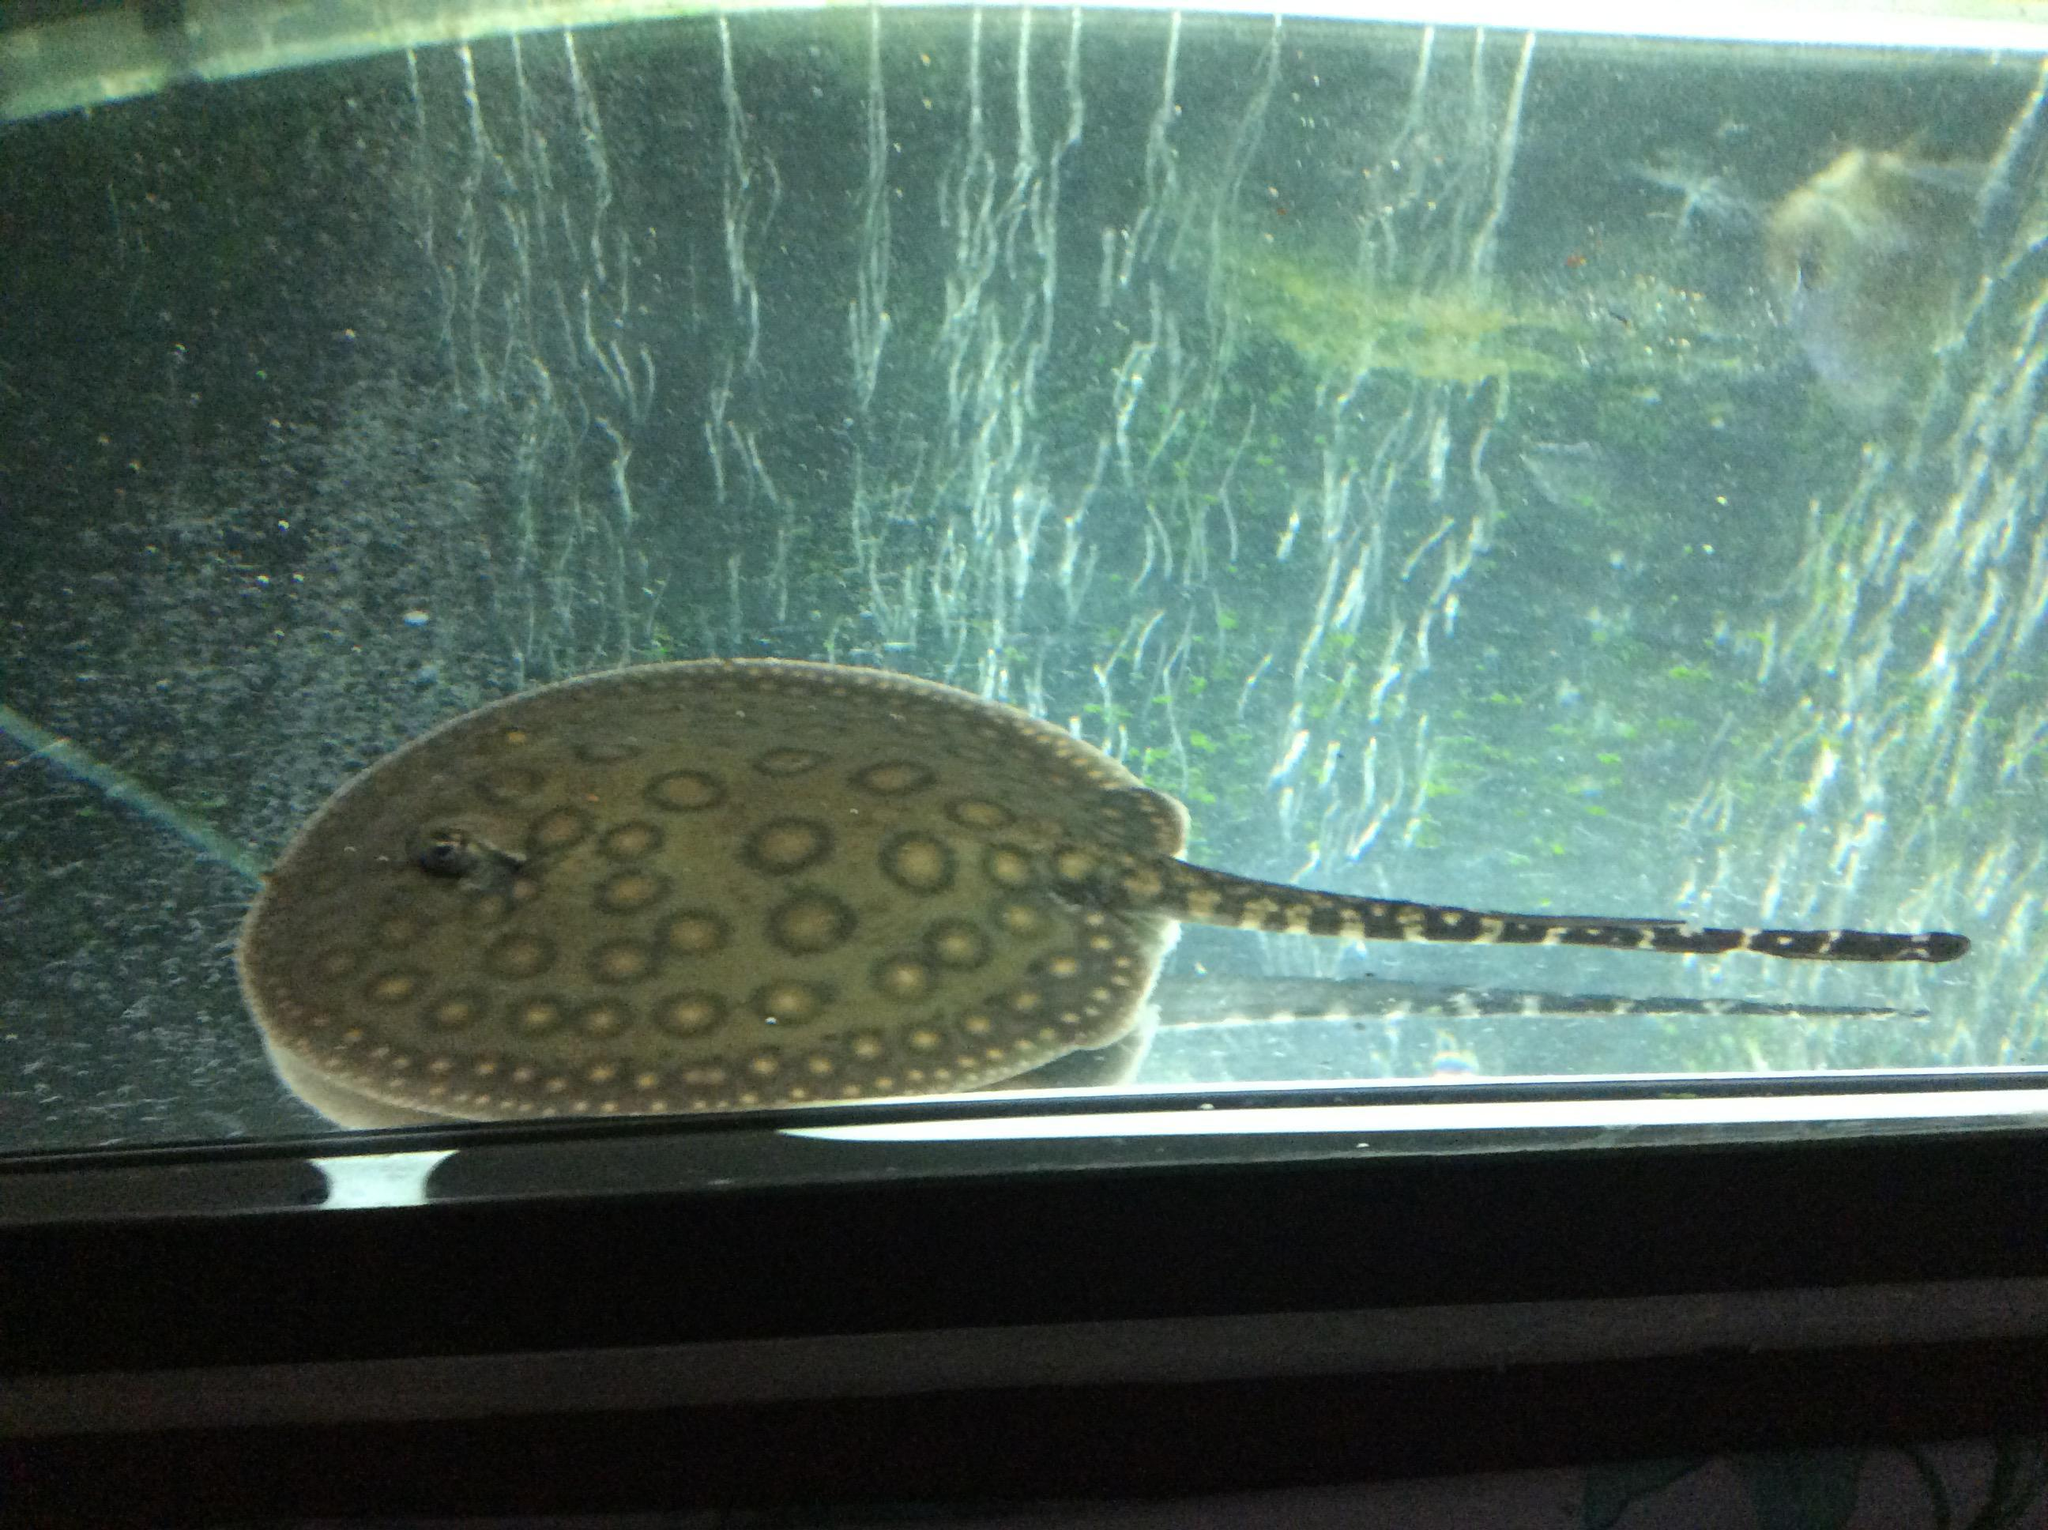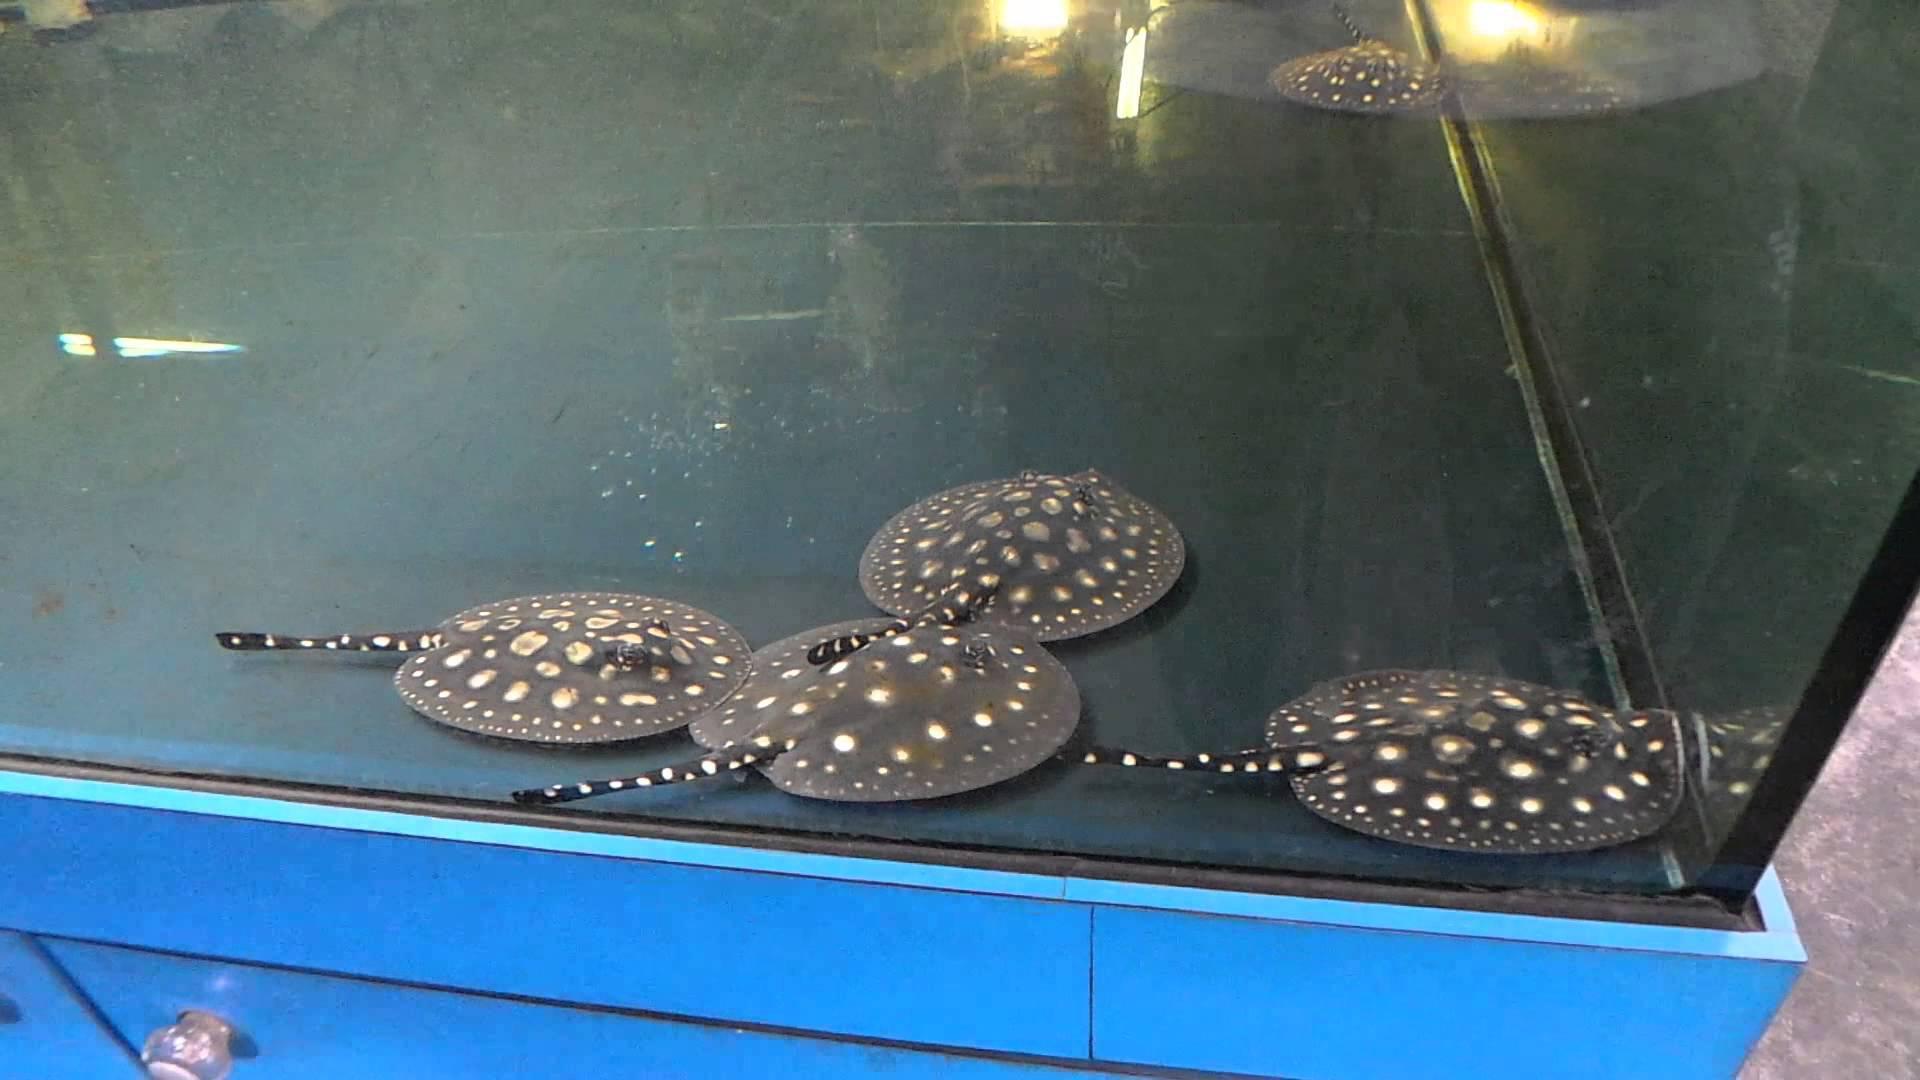The first image is the image on the left, the second image is the image on the right. For the images displayed, is the sentence "No more than 2 animals in any of the pictures" factually correct? Answer yes or no. No. The first image is the image on the left, the second image is the image on the right. Analyze the images presented: Is the assertion "there are 3 stingrays in the image pair" valid? Answer yes or no. No. 